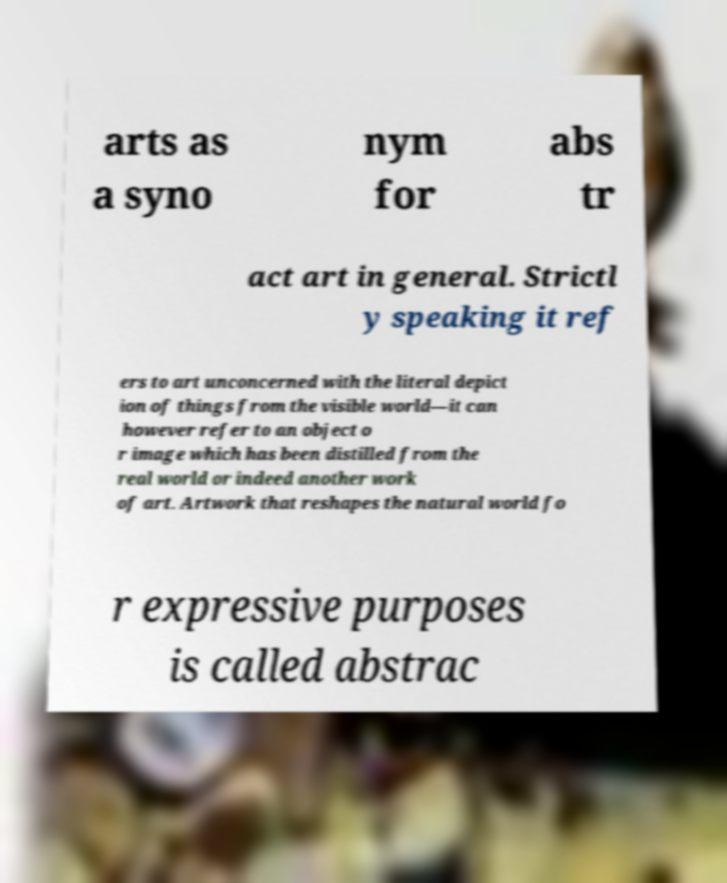Can you accurately transcribe the text from the provided image for me? arts as a syno nym for abs tr act art in general. Strictl y speaking it ref ers to art unconcerned with the literal depict ion of things from the visible world—it can however refer to an object o r image which has been distilled from the real world or indeed another work of art. Artwork that reshapes the natural world fo r expressive purposes is called abstrac 